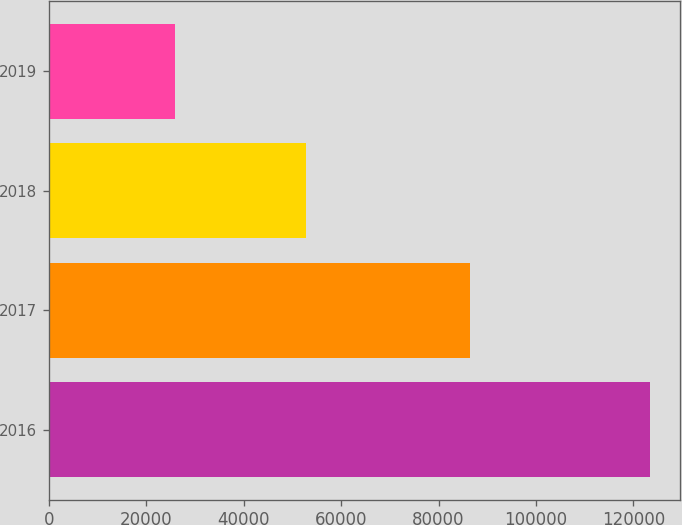Convert chart. <chart><loc_0><loc_0><loc_500><loc_500><bar_chart><fcel>2016<fcel>2017<fcel>2018<fcel>2019<nl><fcel>123388<fcel>86546<fcel>52776<fcel>25928<nl></chart> 